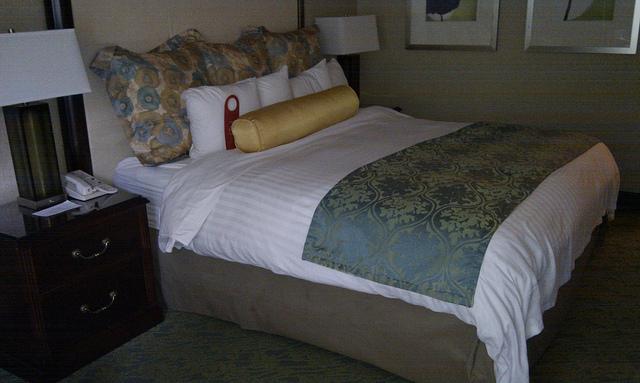How many pillows are on the bed?
Give a very brief answer. 8. Are the black pillows smaller than the white ones?
Be succinct. No. Is anyone in the room?
Be succinct. No. Is the bed made?
Short answer required. Yes. Whose bedroom is this?
Be succinct. Bedroom. How many pictures on the wall?
Short answer required. 2. 